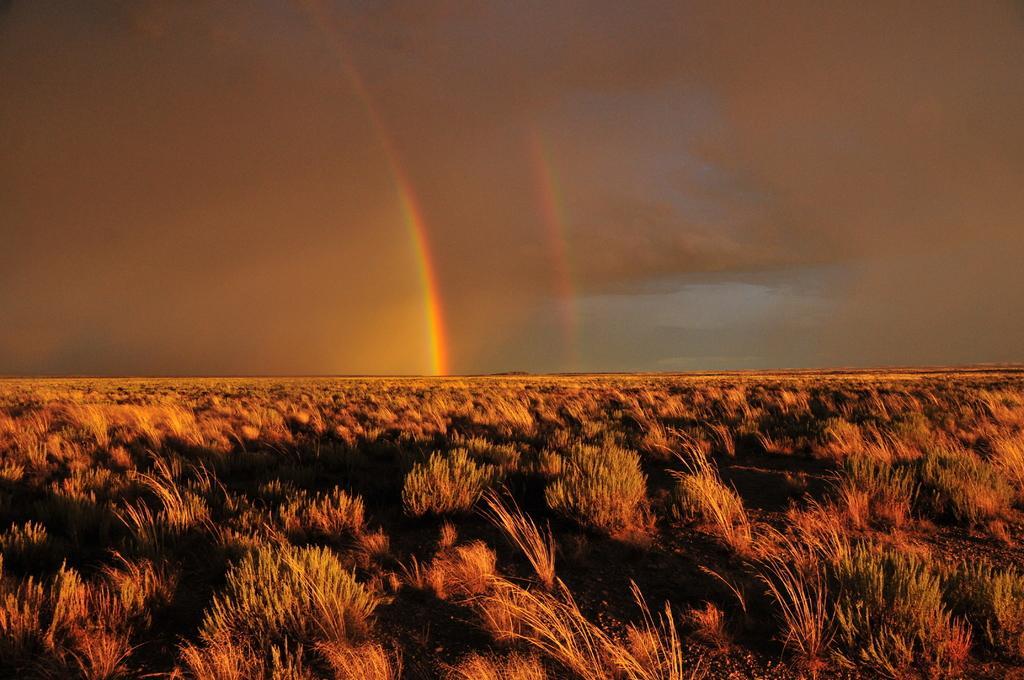Can you describe this image briefly? At the bottom on the ground we can see grass. In the background there are clouds in the sky and a rainbow. 